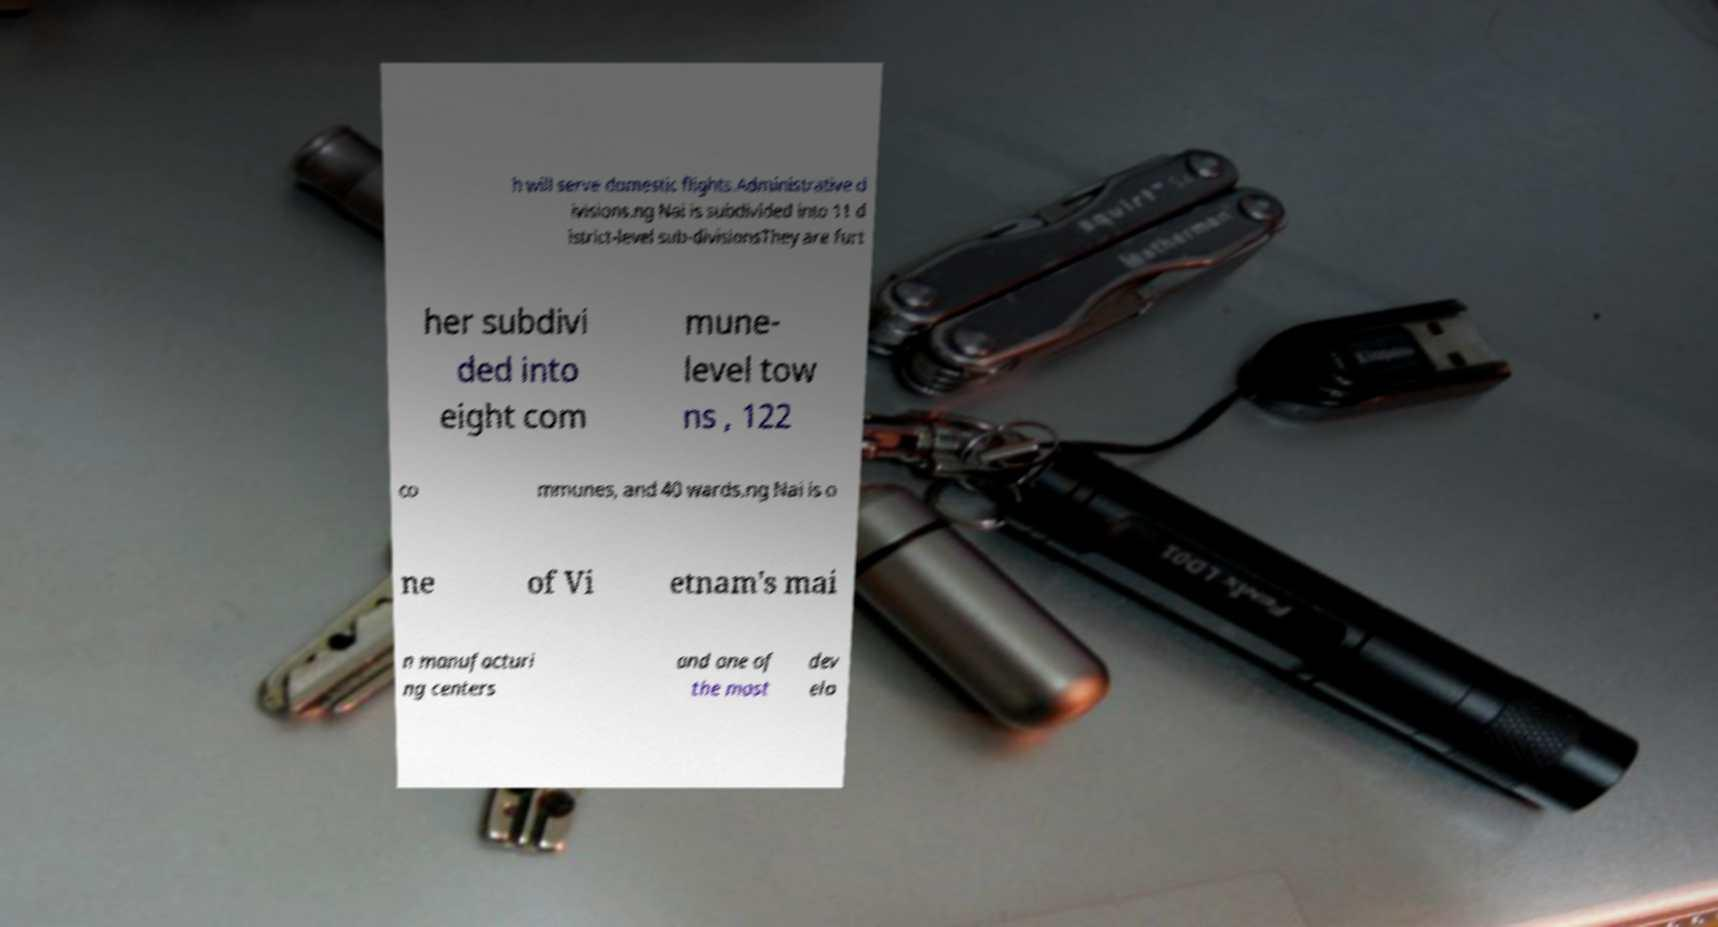There's text embedded in this image that I need extracted. Can you transcribe it verbatim? h will serve domestic flights.Administrative d ivisions.ng Nai is subdivided into 11 d istrict-level sub-divisionsThey are furt her subdivi ded into eight com mune- level tow ns , 122 co mmunes, and 40 wards.ng Nai is o ne of Vi etnam's mai n manufacturi ng centers and one of the most dev elo 